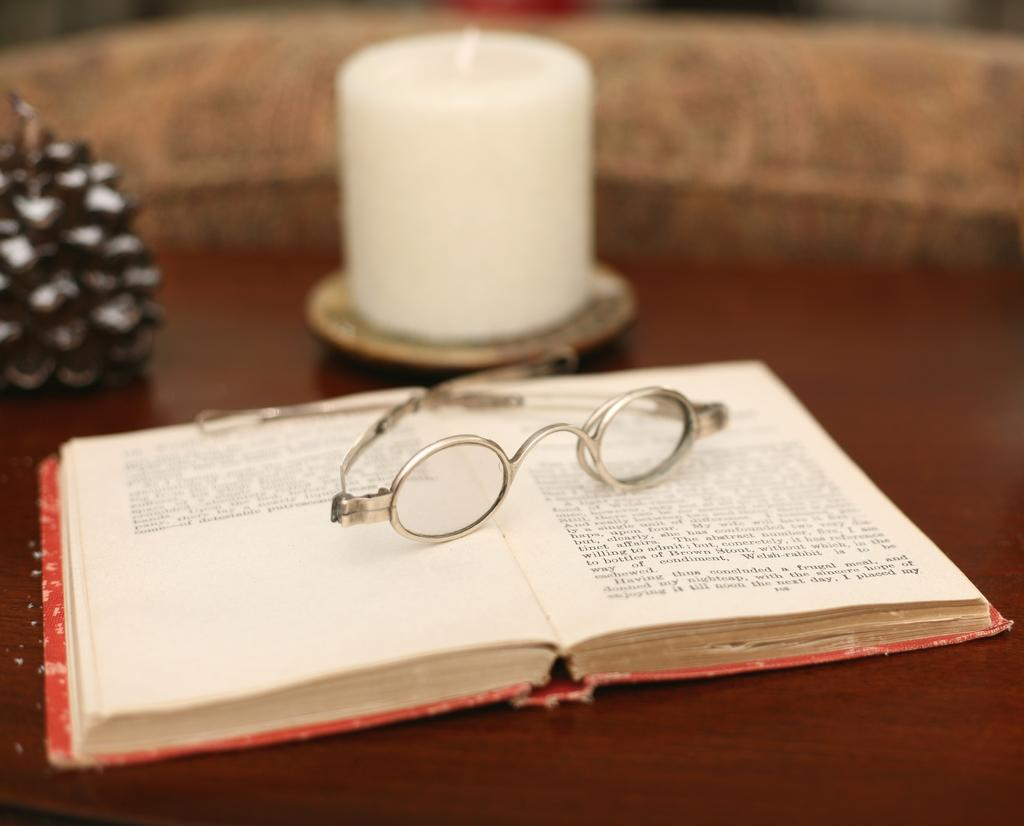What is the main object in the image? There is a book with specs in the image. What other object can be seen in the image? There is a candle in the image. Can you describe the third object in the image? There is an unspecified object in the image. Where was the image taken? The image was taken in a hall. What type of scissors can be seen cutting the turkey in the image? There are no scissors or turkey present in the image. Is the cook visible in the image? There is no cook visible in the image. 